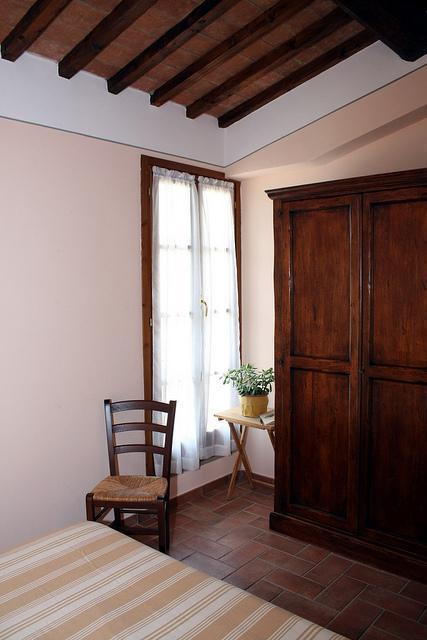How many chairs can be seen?
Give a very brief answer. 1. 